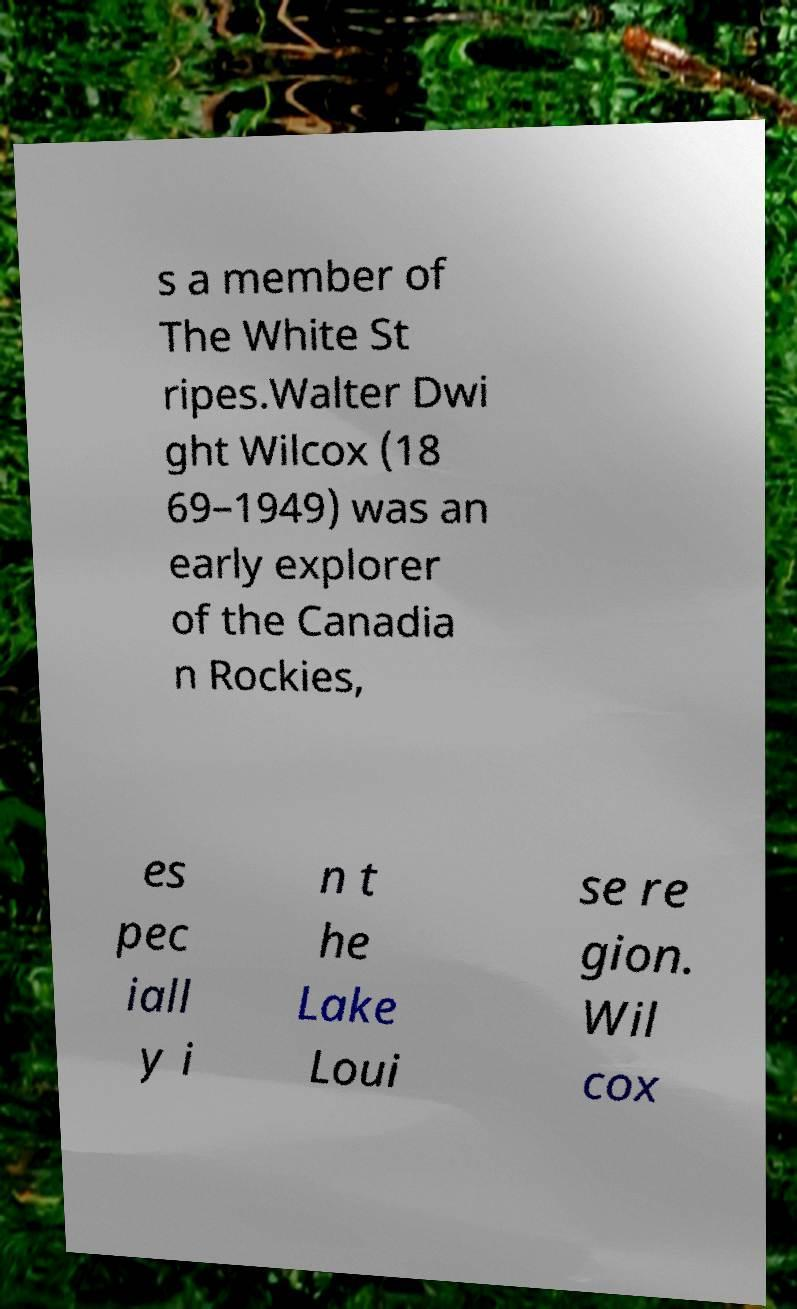Please identify and transcribe the text found in this image. s a member of The White St ripes.Walter Dwi ght Wilcox (18 69–1949) was an early explorer of the Canadia n Rockies, es pec iall y i n t he Lake Loui se re gion. Wil cox 